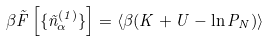Convert formula to latex. <formula><loc_0><loc_0><loc_500><loc_500>\beta { \sl \tilde { F } } \left [ \{ \tilde { n } _ { \alpha } ^ { ( 1 ) } \} \right ] = \left \langle \beta ( K + U - \ln P _ { N } ) \right \rangle</formula> 